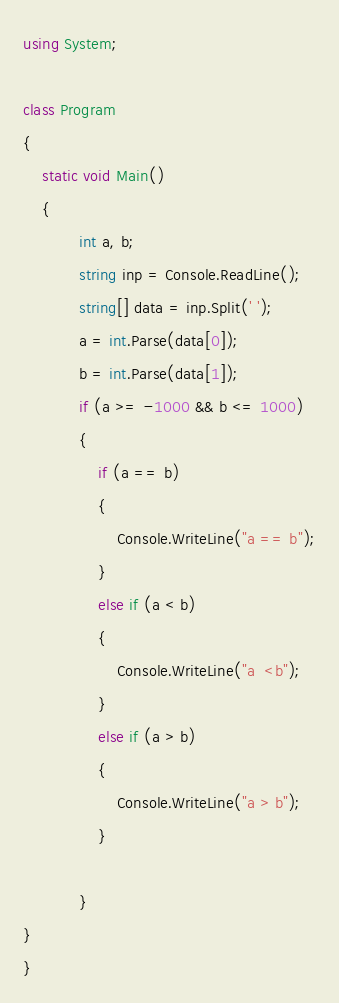Convert code to text. <code><loc_0><loc_0><loc_500><loc_500><_C#_>using System;

class Program
{
    static void Main()
    {
            int a, b;
            string inp = Console.ReadLine();
            string[] data = inp.Split(' ');
            a = int.Parse(data[0]);
            b = int.Parse(data[1]);
            if (a >= -1000 && b <= 1000)
            {
                if (a == b)
                {
                    Console.WriteLine("a == b");
                }
                else if (a < b)
                {
                    Console.WriteLine("a  <b");
                }
                else if (a > b)
                {
                    Console.WriteLine("a > b");
                }

            }
}
}
</code> 